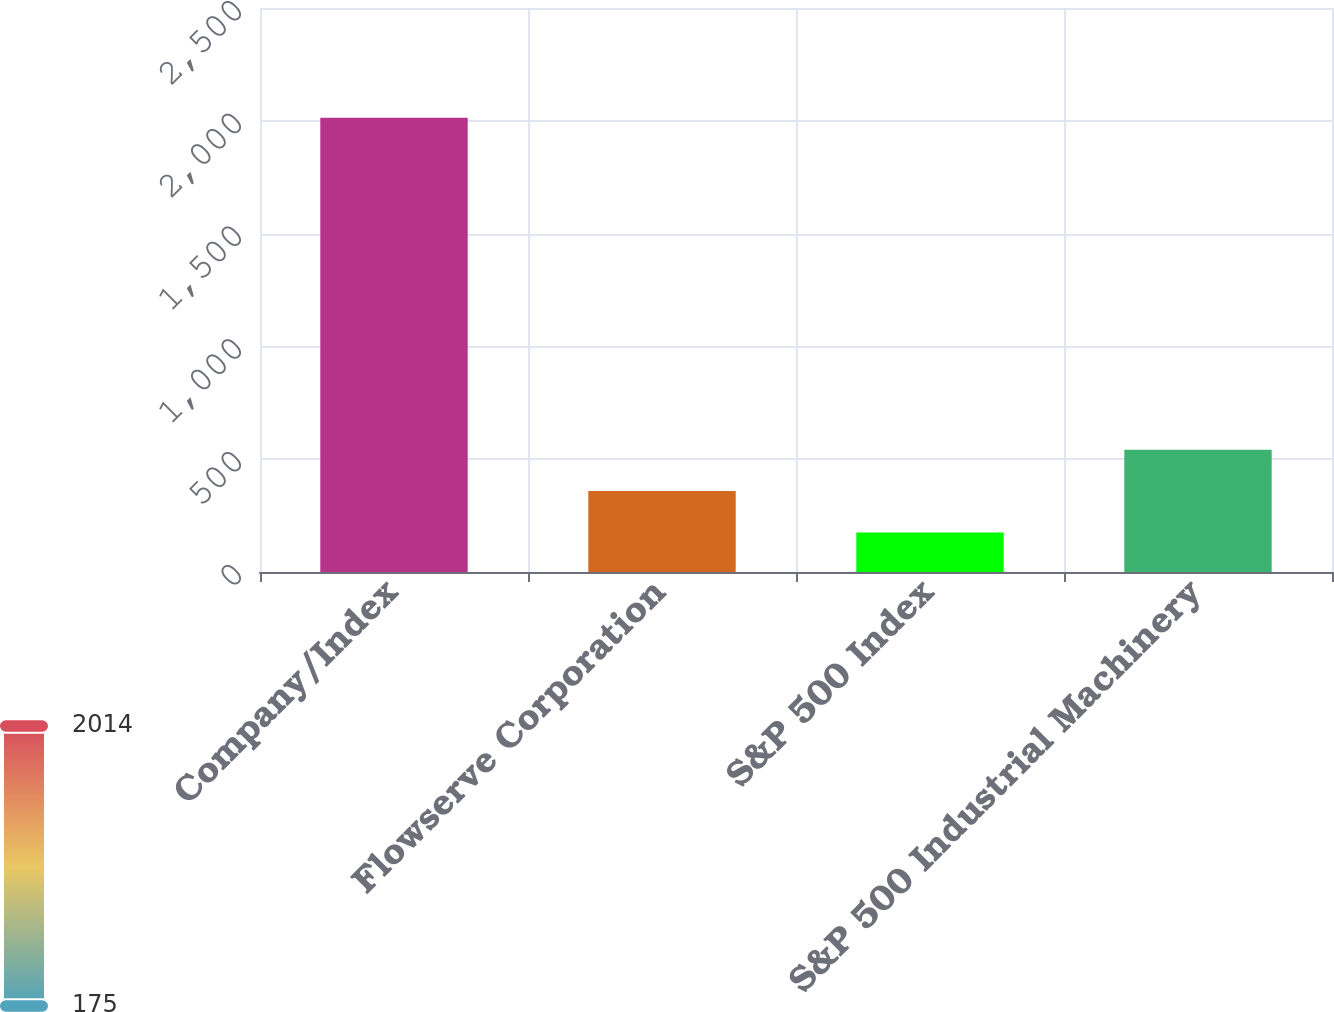<chart> <loc_0><loc_0><loc_500><loc_500><bar_chart><fcel>Company/Index<fcel>Flowserve Corporation<fcel>S&P 500 Index<fcel>S&P 500 Industrial Machinery<nl><fcel>2014<fcel>358.49<fcel>174.54<fcel>542.44<nl></chart> 